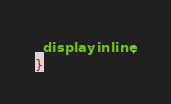<code> <loc_0><loc_0><loc_500><loc_500><_CSS_>  display: inline;
}
</code> 